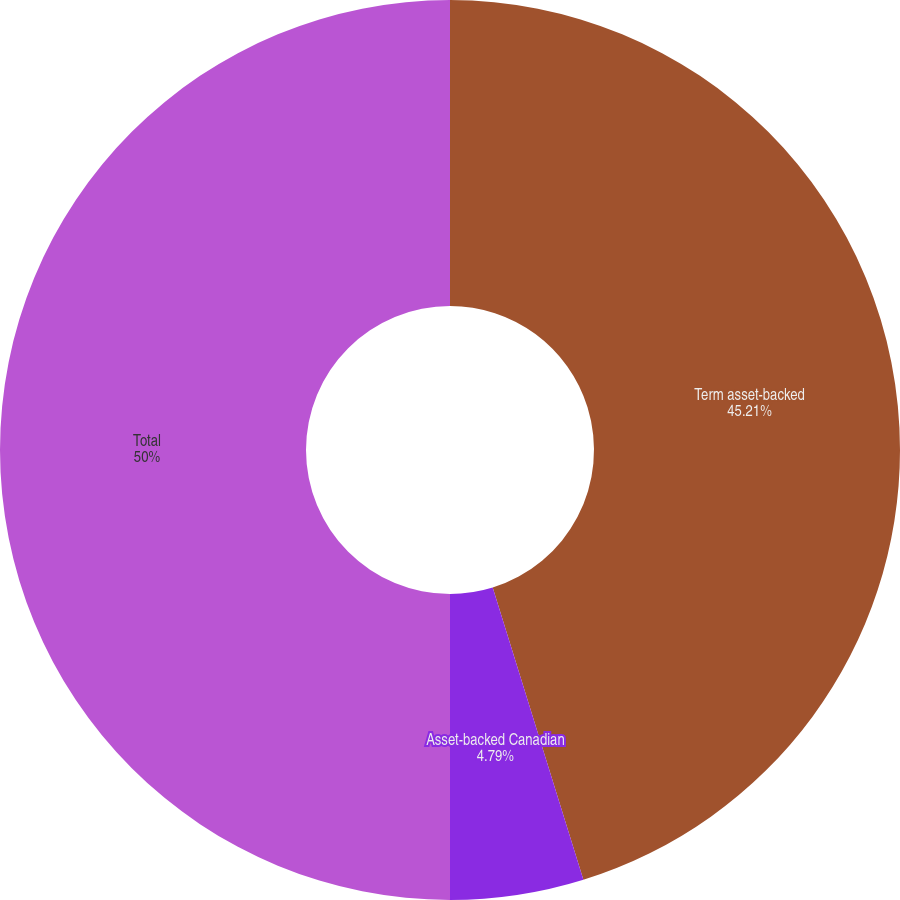<chart> <loc_0><loc_0><loc_500><loc_500><pie_chart><fcel>Term asset-backed<fcel>Asset-backed Canadian<fcel>Total<nl><fcel>45.21%<fcel>4.79%<fcel>50.0%<nl></chart> 